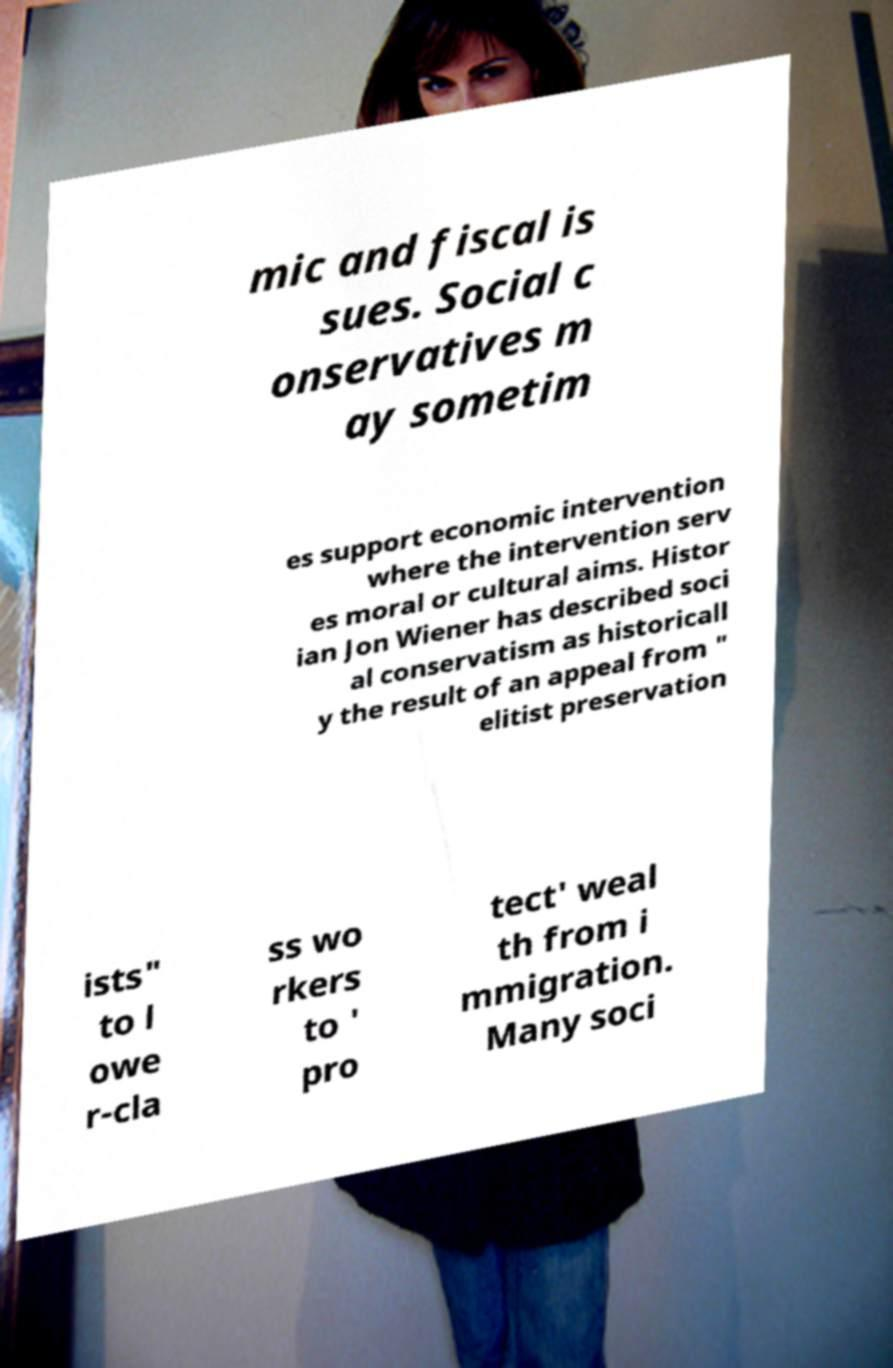There's text embedded in this image that I need extracted. Can you transcribe it verbatim? mic and fiscal is sues. Social c onservatives m ay sometim es support economic intervention where the intervention serv es moral or cultural aims. Histor ian Jon Wiener has described soci al conservatism as historicall y the result of an appeal from " elitist preservation ists" to l owe r-cla ss wo rkers to ' pro tect' weal th from i mmigration. Many soci 